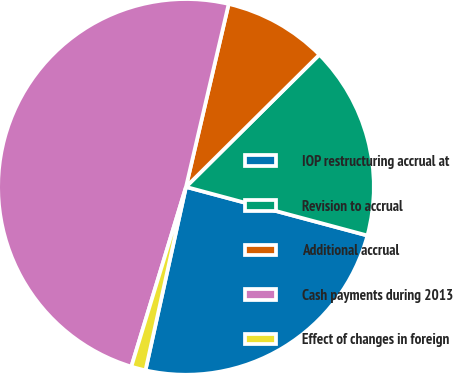Convert chart to OTSL. <chart><loc_0><loc_0><loc_500><loc_500><pie_chart><fcel>IOP restructuring accrual at<fcel>Revision to accrual<fcel>Additional accrual<fcel>Cash payments during 2013<fcel>Effect of changes in foreign<nl><fcel>24.29%<fcel>16.6%<fcel>8.92%<fcel>48.95%<fcel>1.24%<nl></chart> 